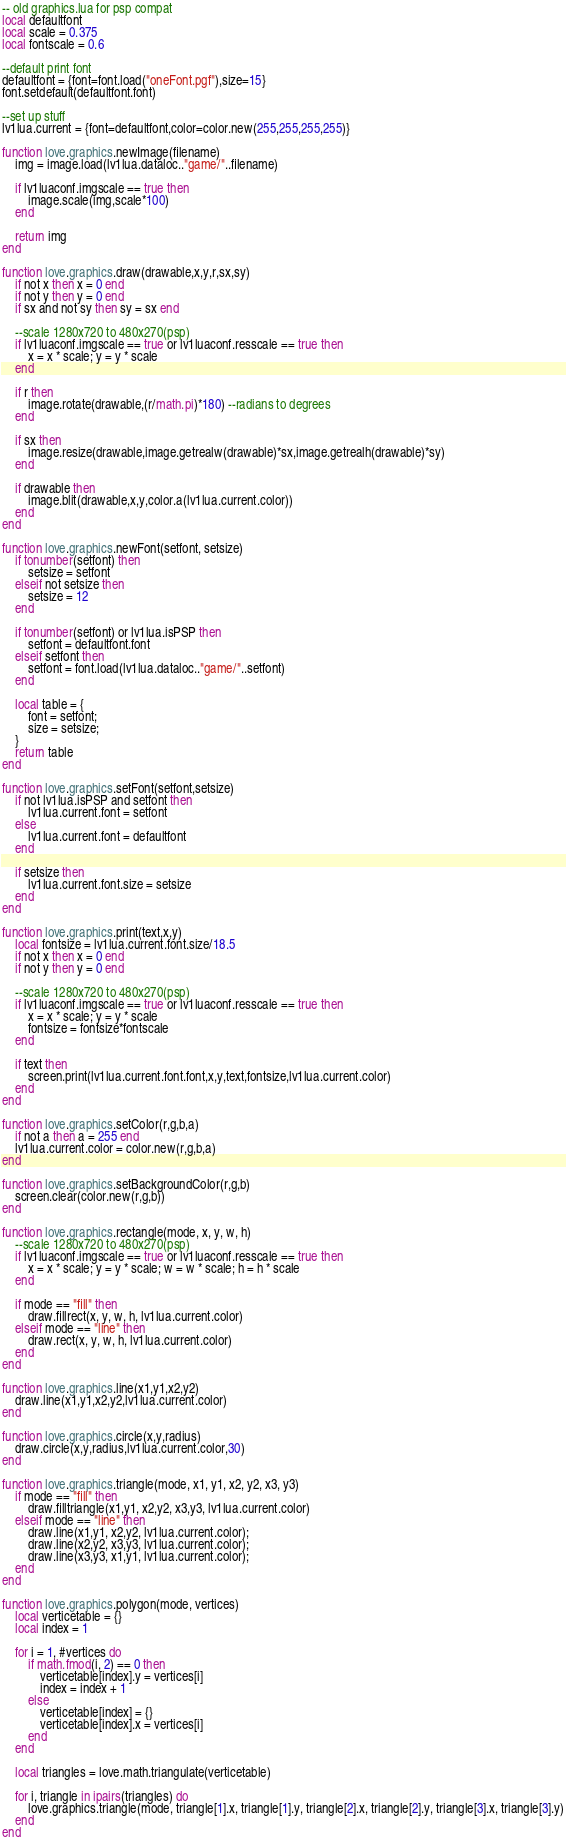Convert code to text. <code><loc_0><loc_0><loc_500><loc_500><_Lua_>-- old graphics.lua for psp compat
local defaultfont
local scale = 0.375
local fontscale = 0.6

--default print font
defaultfont = {font=font.load("oneFont.pgf"),size=15}
font.setdefault(defaultfont.font)

--set up stuff
lv1lua.current = {font=defaultfont,color=color.new(255,255,255,255)}

function love.graphics.newImage(filename)
    img = image.load(lv1lua.dataloc.."game/"..filename)
    
    if lv1luaconf.imgscale == true then
        image.scale(img,scale*100)
    end
    
    return img
end

function love.graphics.draw(drawable,x,y,r,sx,sy)
    if not x then x = 0 end
    if not y then y = 0 end
    if sx and not sy then sy = sx end
    
    --scale 1280x720 to 480x270(psp)
    if lv1luaconf.imgscale == true or lv1luaconf.resscale == true then
        x = x * scale; y = y * scale
    end
    
    if r then
        image.rotate(drawable,(r/math.pi)*180) --radians to degrees
    end
    
    if sx then
        image.resize(drawable,image.getrealw(drawable)*sx,image.getrealh(drawable)*sy)
    end
    
    if drawable then
        image.blit(drawable,x,y,color.a(lv1lua.current.color))
    end
end

function love.graphics.newFont(setfont, setsize)
    if tonumber(setfont) then
        setsize = setfont
    elseif not setsize then
        setsize = 12
    end
    
    if tonumber(setfont) or lv1lua.isPSP then
        setfont = defaultfont.font
    elseif setfont then
        setfont = font.load(lv1lua.dataloc.."game/"..setfont)
    end
        
    local table = {
        font = setfont;
        size = setsize;
    }
    return table
end

function love.graphics.setFont(setfont,setsize)
    if not lv1lua.isPSP and setfont then
        lv1lua.current.font = setfont
    else
        lv1lua.current.font = defaultfont
    end
    
    if setsize then
        lv1lua.current.font.size = setsize
    end
end

function love.graphics.print(text,x,y)
    local fontsize = lv1lua.current.font.size/18.5
    if not x then x = 0 end
    if not y then y = 0 end
    
    --scale 1280x720 to 480x270(psp)
    if lv1luaconf.imgscale == true or lv1luaconf.resscale == true then
        x = x * scale; y = y * scale
        fontsize = fontsize*fontscale
    end
    
    if text then
        screen.print(lv1lua.current.font.font,x,y,text,fontsize,lv1lua.current.color)
    end
end

function love.graphics.setColor(r,g,b,a)
    if not a then a = 255 end
    lv1lua.current.color = color.new(r,g,b,a)
end

function love.graphics.setBackgroundColor(r,g,b)
    screen.clear(color.new(r,g,b))
end

function love.graphics.rectangle(mode, x, y, w, h)
    --scale 1280x720 to 480x270(psp)
    if lv1luaconf.imgscale == true or lv1luaconf.resscale == true then
        x = x * scale; y = y * scale; w = w * scale; h = h * scale
    end
    
    if mode == "fill" then
        draw.fillrect(x, y, w, h, lv1lua.current.color)
    elseif mode == "line" then
        draw.rect(x, y, w, h, lv1lua.current.color)
    end
end

function love.graphics.line(x1,y1,x2,y2)
    draw.line(x1,y1,x2,y2,lv1lua.current.color)
end

function love.graphics.circle(x,y,radius)
    draw.circle(x,y,radius,lv1lua.current.color,30)
end

function love.graphics.triangle(mode, x1, y1, x2, y2, x3, y3)
    if mode == "fill" then
        draw.filltriangle(x1,y1, x2,y2, x3,y3, lv1lua.current.color)
    elseif mode == "line" then
        draw.line(x1,y1, x2,y2, lv1lua.current.color);
        draw.line(x2,y2, x3,y3, lv1lua.current.color);
        draw.line(x3,y3, x1,y1, lv1lua.current.color);
    end
end

function love.graphics.polygon(mode, vertices) 
    local verticetable = {}
    local index = 1

    for i = 1, #vertices do
        if math.fmod(i, 2) == 0 then
            verticetable[index].y = vertices[i]
            index = index + 1
        else
            verticetable[index] = {}
            verticetable[index].x = vertices[i]
        end
    end

    local triangles = love.math.triangulate(verticetable)

    for i, triangle in ipairs(triangles) do
        love.graphics.triangle(mode, triangle[1].x, triangle[1].y, triangle[2].x, triangle[2].y, triangle[3].x, triangle[3].y)
    end
end
</code> 